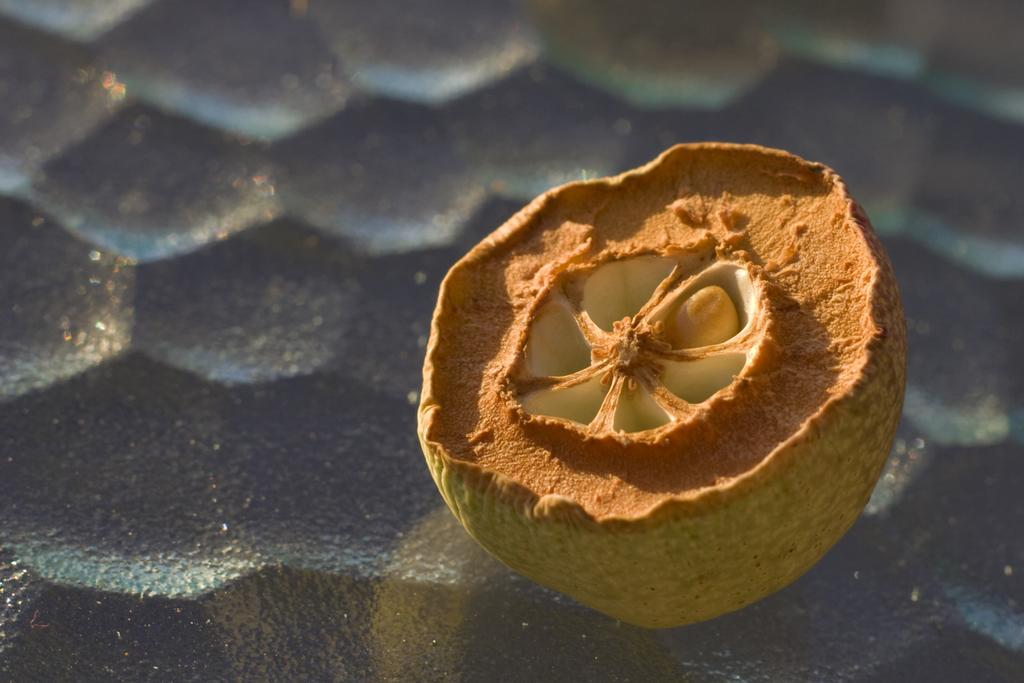What type of food can be seen in the image? There is fruit in the image. Where is the fruit located? The fruit is kept on the ground. What type of government is depicted in the image? There is no government depicted in the image; it features fruit on the ground. Can you hear the fruit in the image? The fruit in the image is not making any sound, so it cannot be heard. 